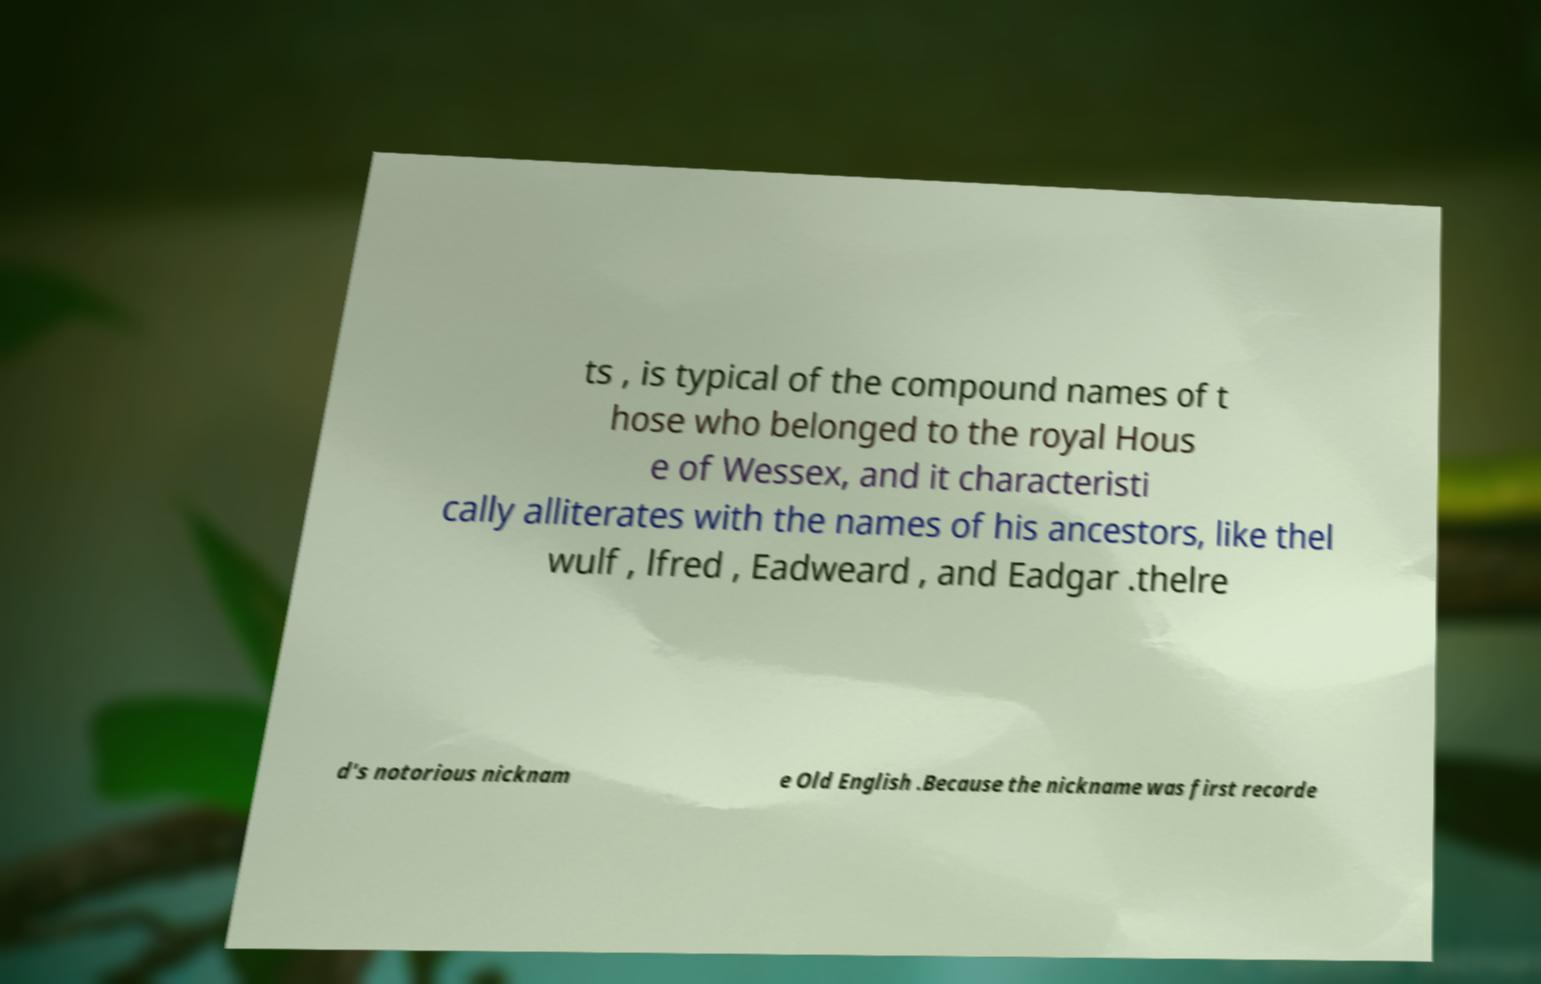What messages or text are displayed in this image? I need them in a readable, typed format. ts , is typical of the compound names of t hose who belonged to the royal Hous e of Wessex, and it characteristi cally alliterates with the names of his ancestors, like thel wulf , lfred , Eadweard , and Eadgar .thelre d's notorious nicknam e Old English .Because the nickname was first recorde 